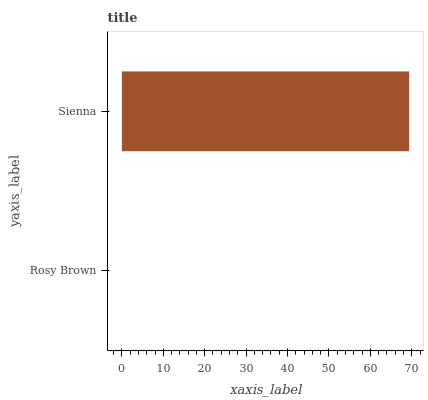Is Rosy Brown the minimum?
Answer yes or no. Yes. Is Sienna the maximum?
Answer yes or no. Yes. Is Sienna the minimum?
Answer yes or no. No. Is Sienna greater than Rosy Brown?
Answer yes or no. Yes. Is Rosy Brown less than Sienna?
Answer yes or no. Yes. Is Rosy Brown greater than Sienna?
Answer yes or no. No. Is Sienna less than Rosy Brown?
Answer yes or no. No. Is Sienna the high median?
Answer yes or no. Yes. Is Rosy Brown the low median?
Answer yes or no. Yes. Is Rosy Brown the high median?
Answer yes or no. No. Is Sienna the low median?
Answer yes or no. No. 